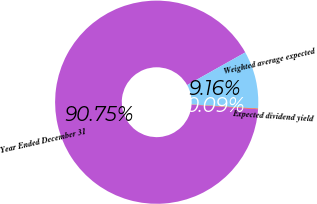Convert chart to OTSL. <chart><loc_0><loc_0><loc_500><loc_500><pie_chart><fcel>Year Ended December 31<fcel>Weighted average expected<fcel>Expected dividend yield<nl><fcel>90.75%<fcel>9.16%<fcel>0.09%<nl></chart> 